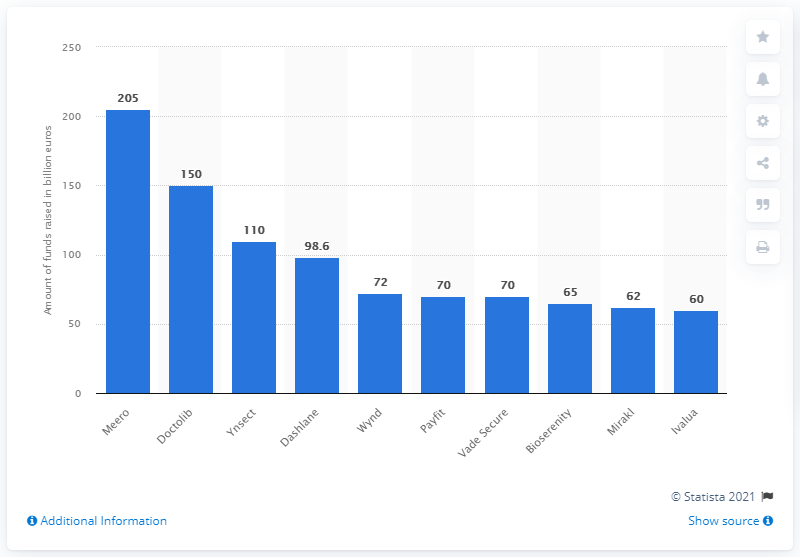Specify some key components in this picture. The Franco-German company known as Doctolib provides services to healthcare professionals and patients. Meero raised 205 million euros in the first semester of 2019. 